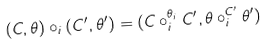<formula> <loc_0><loc_0><loc_500><loc_500>( C , \theta ) \circ _ { i } ( C ^ { \prime } , \theta ^ { \prime } ) = ( C \circ _ { i } ^ { \theta _ { i } } C ^ { \prime } , \theta \circ _ { i } ^ { C ^ { \prime } } \theta ^ { \prime } )</formula> 